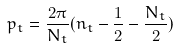<formula> <loc_0><loc_0><loc_500><loc_500>p _ { t } = \frac { 2 \pi } { N _ { t } } ( n _ { t } - \frac { 1 } { 2 } - \frac { N _ { t } } { 2 } )</formula> 